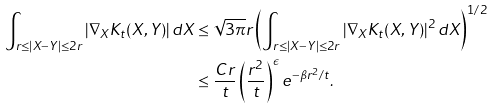<formula> <loc_0><loc_0><loc_500><loc_500>\int _ { r \leq | X - Y | \leq 2 r } | \nabla _ { X } K _ { t } ( X , Y ) | \, d X & \leq \sqrt { 3 \pi } r \left ( \int _ { r \leq | X - Y | \leq 2 r } | \nabla _ { X } K _ { t } ( X , Y ) | ^ { 2 } \, d X \right ) ^ { 1 / 2 } \\ & \leq \frac { C r } { t } \left ( \frac { r ^ { 2 } } { t } \right ) ^ { \epsilon } e ^ { - \beta r ^ { 2 } / t } .</formula> 